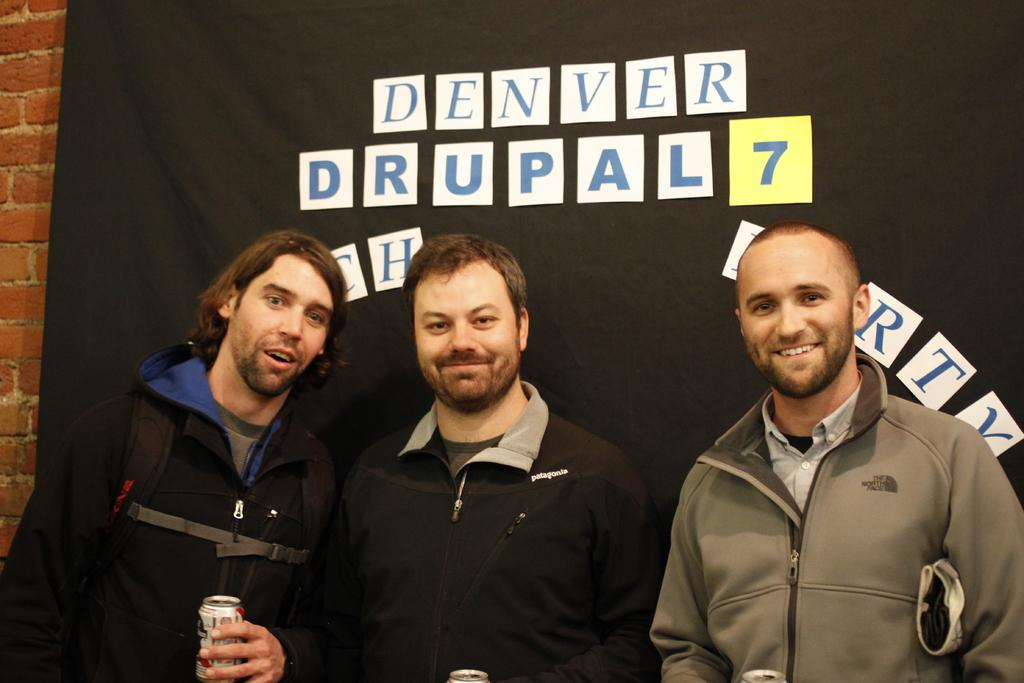<image>
Share a concise interpretation of the image provided. A group of three men are standing under a black sheet that says Denver Drupal 7. 